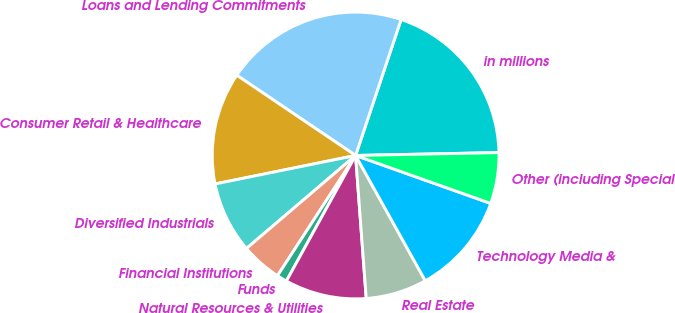<chart> <loc_0><loc_0><loc_500><loc_500><pie_chart><fcel>in millions<fcel>Loans and Lending Commitments<fcel>Consumer Retail & Healthcare<fcel>Diversified Industrials<fcel>Financial Institutions<fcel>Funds<fcel>Natural Resources & Utilities<fcel>Real Estate<fcel>Technology Media &<fcel>Other (including Special<nl><fcel>19.54%<fcel>20.69%<fcel>12.64%<fcel>8.05%<fcel>4.6%<fcel>1.15%<fcel>9.2%<fcel>6.9%<fcel>11.49%<fcel>5.75%<nl></chart> 